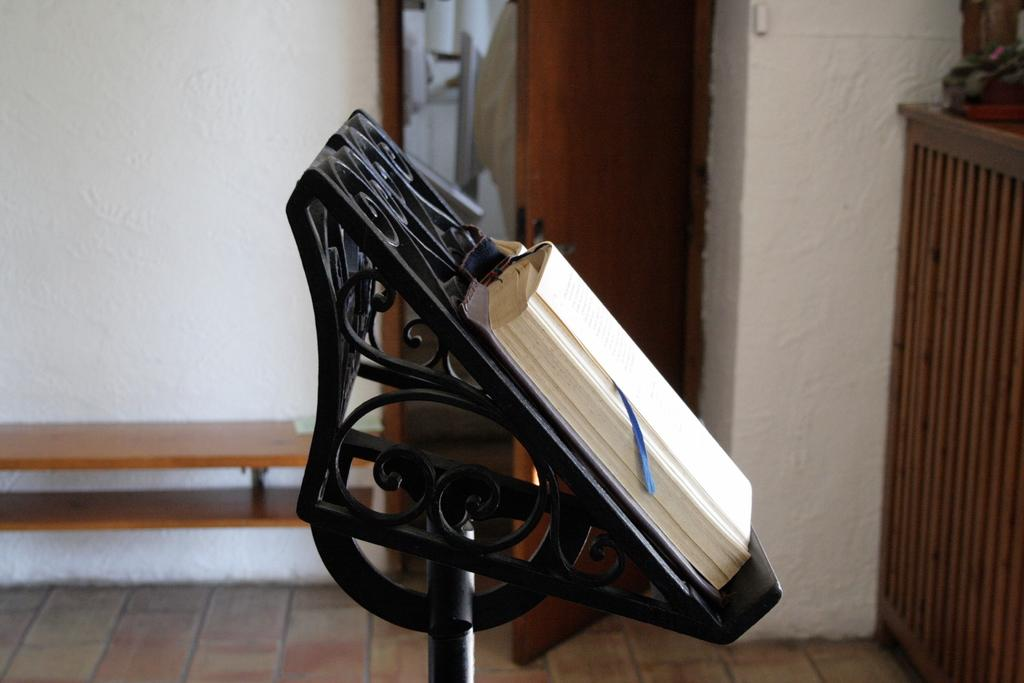What is placed on a stand in the image? There is a book on a stand in the image. What type of furniture can be seen in the background of the image? There is a wooden bench in the background of the image. What architectural feature is visible in the background of the image? There is a door to a room in the background of the image. What wooden object is on the right side of the image? There is a wooden object on the right side of the image. What type of holiday is being celebrated in the image? There is no indication of a holiday being celebrated in the image. Is there a volcano visible in the image? No, there is no volcano present in the image. 